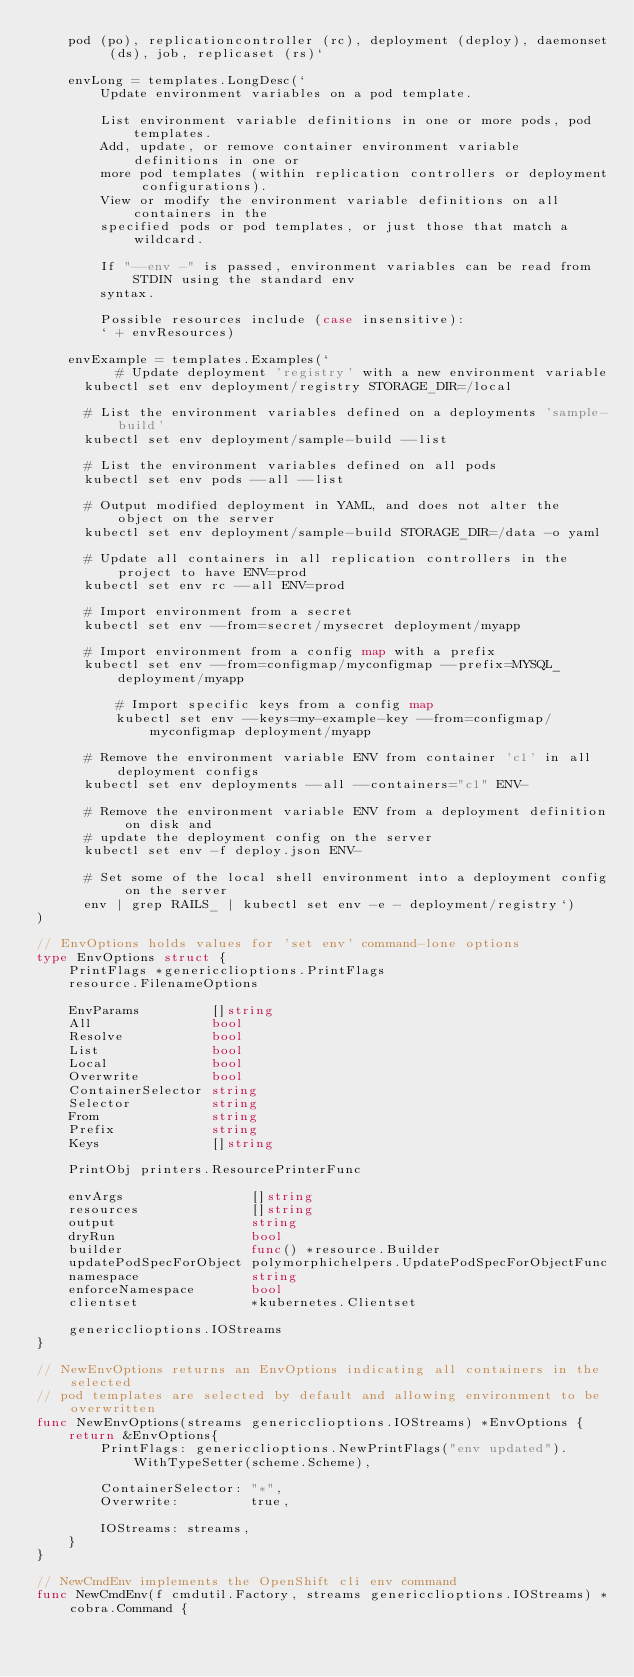<code> <loc_0><loc_0><loc_500><loc_500><_Go_>  	pod (po), replicationcontroller (rc), deployment (deploy), daemonset (ds), job, replicaset (rs)`

	envLong = templates.LongDesc(`
		Update environment variables on a pod template.

		List environment variable definitions in one or more pods, pod templates.
		Add, update, or remove container environment variable definitions in one or
		more pod templates (within replication controllers or deployment configurations).
		View or modify the environment variable definitions on all containers in the
		specified pods or pod templates, or just those that match a wildcard.

		If "--env -" is passed, environment variables can be read from STDIN using the standard env
		syntax.

		Possible resources include (case insensitive):
		` + envResources)

	envExample = templates.Examples(`
          # Update deployment 'registry' with a new environment variable
	  kubectl set env deployment/registry STORAGE_DIR=/local

	  # List the environment variables defined on a deployments 'sample-build'
	  kubectl set env deployment/sample-build --list

	  # List the environment variables defined on all pods
	  kubectl set env pods --all --list

	  # Output modified deployment in YAML, and does not alter the object on the server
	  kubectl set env deployment/sample-build STORAGE_DIR=/data -o yaml

	  # Update all containers in all replication controllers in the project to have ENV=prod
	  kubectl set env rc --all ENV=prod

	  # Import environment from a secret
	  kubectl set env --from=secret/mysecret deployment/myapp

	  # Import environment from a config map with a prefix
	  kubectl set env --from=configmap/myconfigmap --prefix=MYSQL_ deployment/myapp

          # Import specific keys from a config map
          kubectl set env --keys=my-example-key --from=configmap/myconfigmap deployment/myapp

	  # Remove the environment variable ENV from container 'c1' in all deployment configs
	  kubectl set env deployments --all --containers="c1" ENV-

	  # Remove the environment variable ENV from a deployment definition on disk and
	  # update the deployment config on the server
	  kubectl set env -f deploy.json ENV-

	  # Set some of the local shell environment into a deployment config on the server
	  env | grep RAILS_ | kubectl set env -e - deployment/registry`)
)

// EnvOptions holds values for 'set env' command-lone options
type EnvOptions struct {
	PrintFlags *genericclioptions.PrintFlags
	resource.FilenameOptions

	EnvParams         []string
	All               bool
	Resolve           bool
	List              bool
	Local             bool
	Overwrite         bool
	ContainerSelector string
	Selector          string
	From              string
	Prefix            string
	Keys              []string

	PrintObj printers.ResourcePrinterFunc

	envArgs                []string
	resources              []string
	output                 string
	dryRun                 bool
	builder                func() *resource.Builder
	updatePodSpecForObject polymorphichelpers.UpdatePodSpecForObjectFunc
	namespace              string
	enforceNamespace       bool
	clientset              *kubernetes.Clientset

	genericclioptions.IOStreams
}

// NewEnvOptions returns an EnvOptions indicating all containers in the selected
// pod templates are selected by default and allowing environment to be overwritten
func NewEnvOptions(streams genericclioptions.IOStreams) *EnvOptions {
	return &EnvOptions{
		PrintFlags: genericclioptions.NewPrintFlags("env updated").WithTypeSetter(scheme.Scheme),

		ContainerSelector: "*",
		Overwrite:         true,

		IOStreams: streams,
	}
}

// NewCmdEnv implements the OpenShift cli env command
func NewCmdEnv(f cmdutil.Factory, streams genericclioptions.IOStreams) *cobra.Command {</code> 